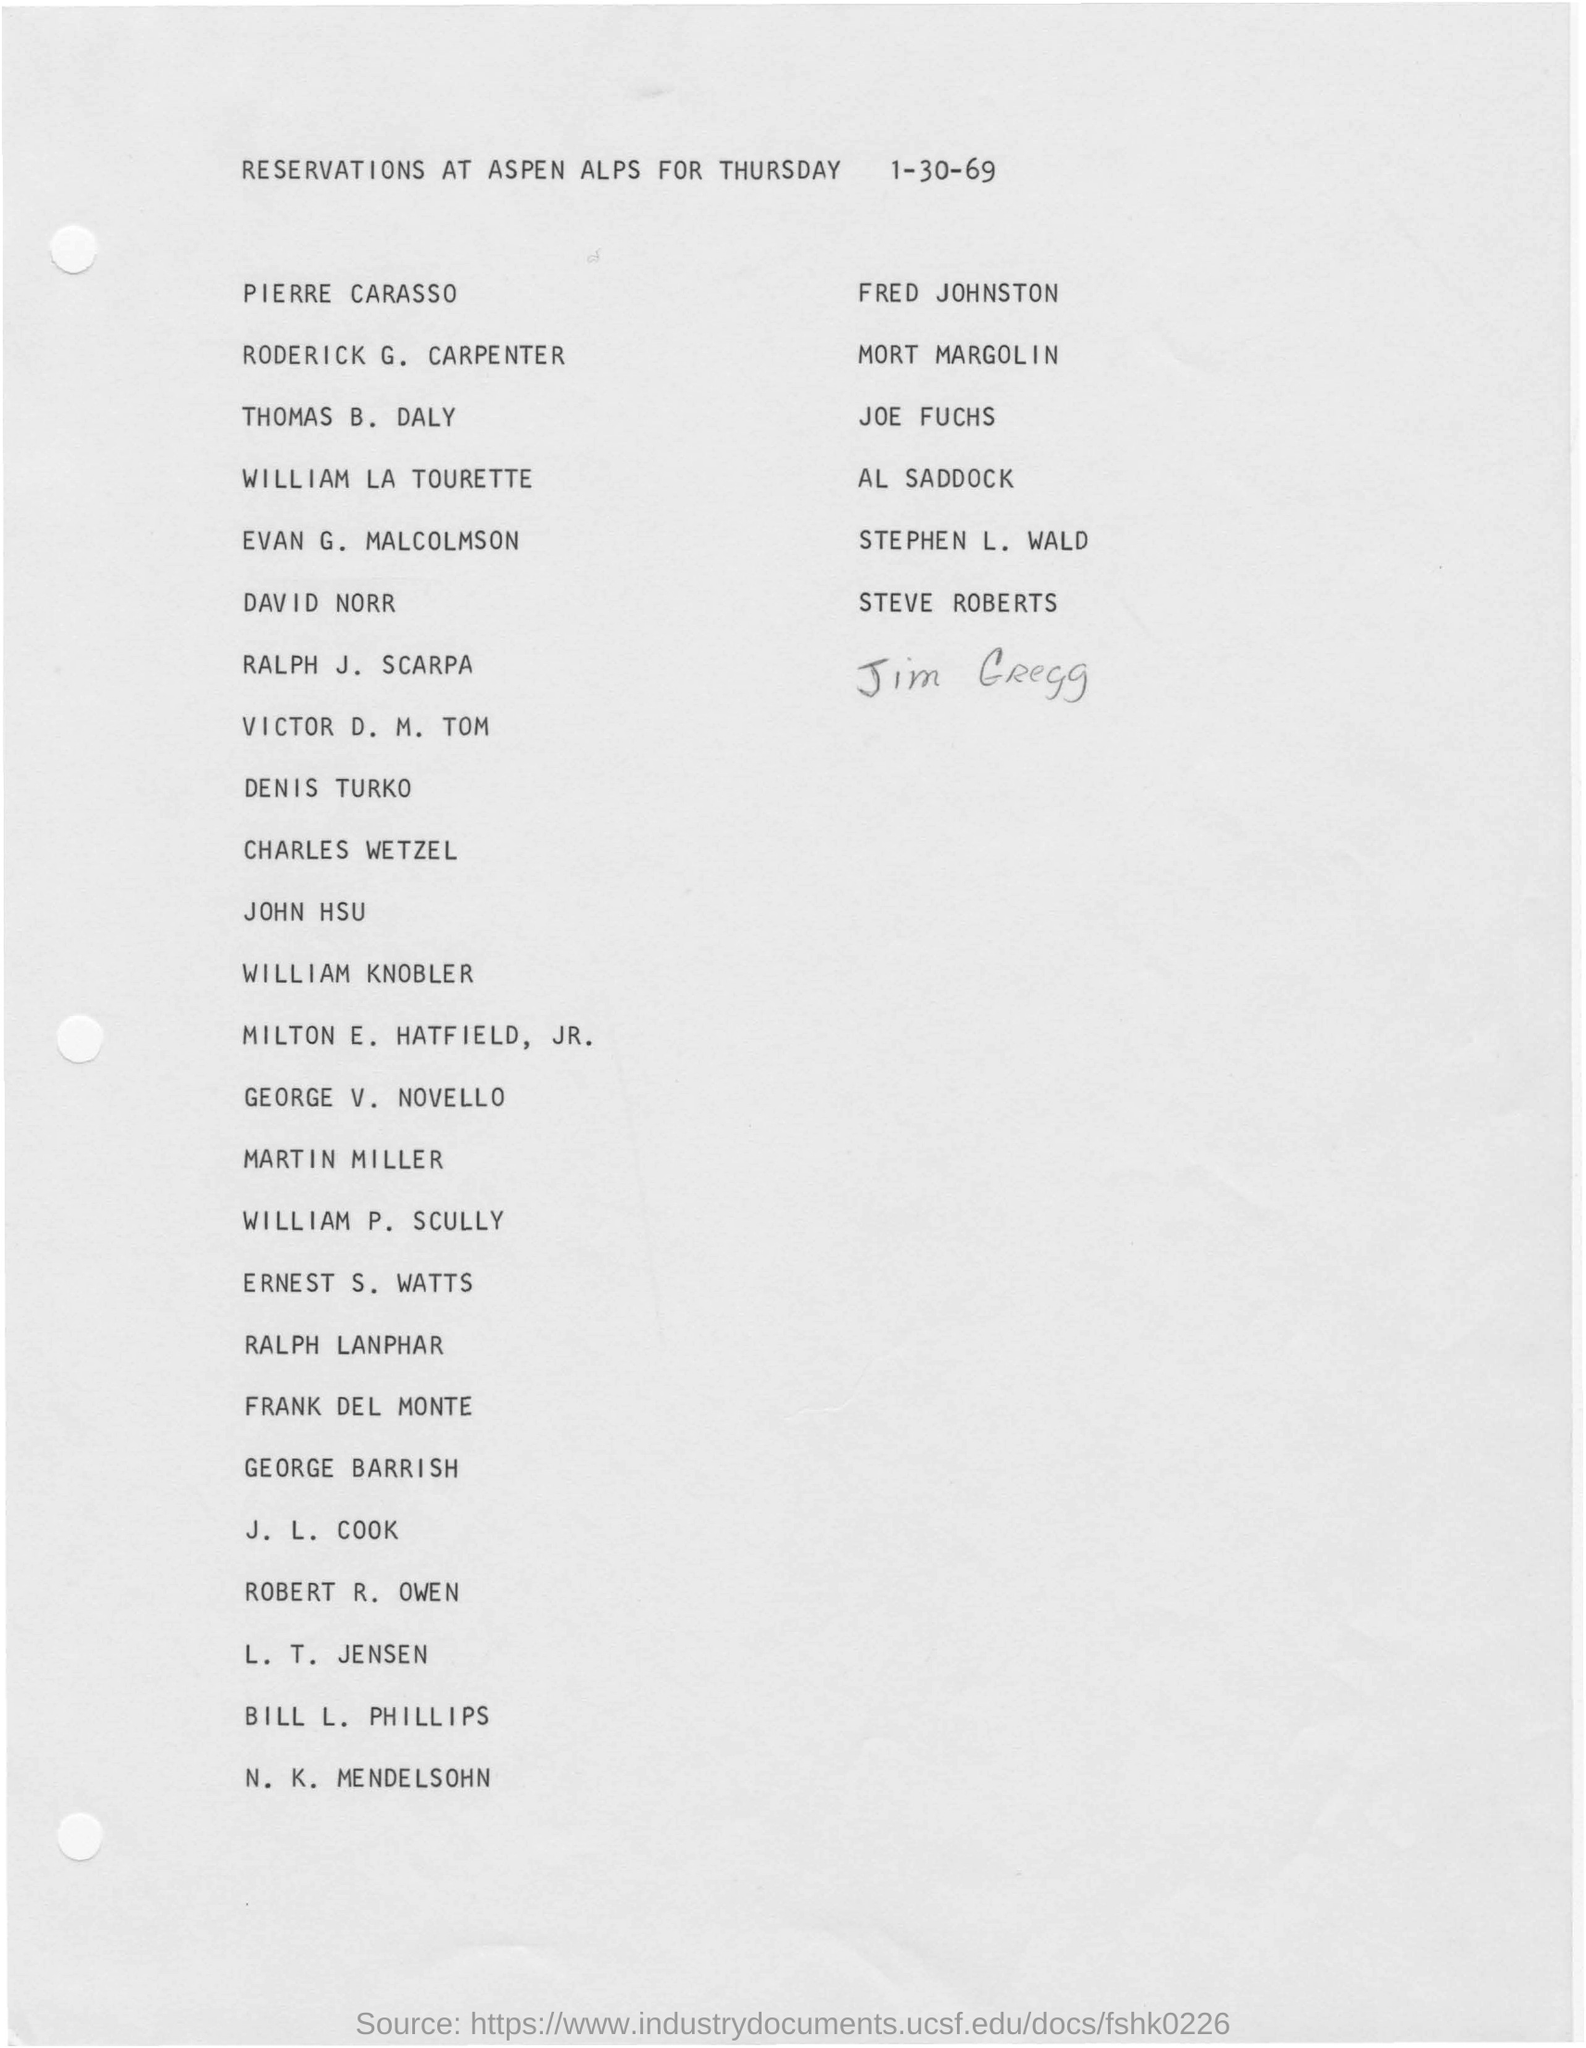Which is the last name added/
Your answer should be very brief. Jim Gregg. When the document dated?
Offer a very short reply. 1-30-69. What is the fourth name listed?
Your answer should be compact. William la tourette. 